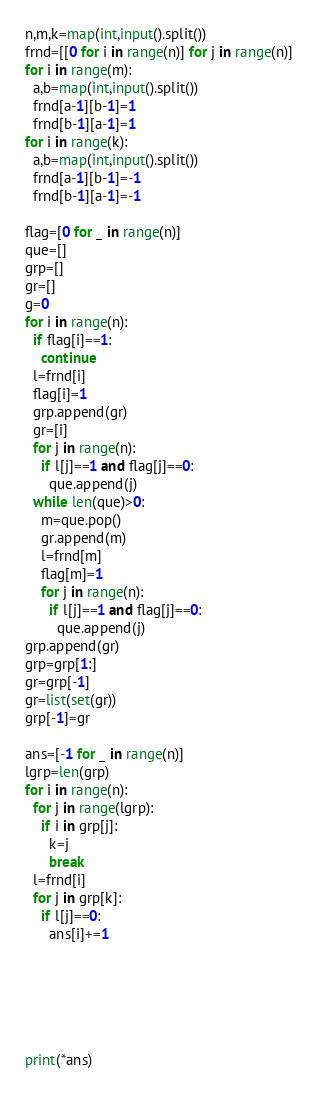<code> <loc_0><loc_0><loc_500><loc_500><_Python_>n,m,k=map(int,input().split())
frnd=[[0 for i in range(n)] for j in range(n)]
for i in range(m):
  a,b=map(int,input().split())
  frnd[a-1][b-1]=1
  frnd[b-1][a-1]=1
for i in range(k):
  a,b=map(int,input().split())
  frnd[a-1][b-1]=-1
  frnd[b-1][a-1]=-1

flag=[0 for _ in range(n)]
que=[]
grp=[]
gr=[]
g=0
for i in range(n):
  if flag[i]==1:
    continue
  l=frnd[i]
  flag[i]=1
  grp.append(gr)
  gr=[i]
  for j in range(n):
    if l[j]==1 and flag[j]==0:
      que.append(j)
  while len(que)>0:
    m=que.pop()
    gr.append(m)
    l=frnd[m]
    flag[m]=1
    for j in range(n):
      if l[j]==1 and flag[j]==0:
        que.append(j)
grp.append(gr)    
grp=grp[1:]
gr=grp[-1]
gr=list(set(gr))
grp[-1]=gr

ans=[-1 for _ in range(n)]
lgrp=len(grp)
for i in range(n):
  for j in range(lgrp):
    if i in grp[j]:
      k=j
      break
  l=frnd[i]
  for j in grp[k]:
    if l[j]==0:
      ans[i]+=1






print(*ans)

</code> 